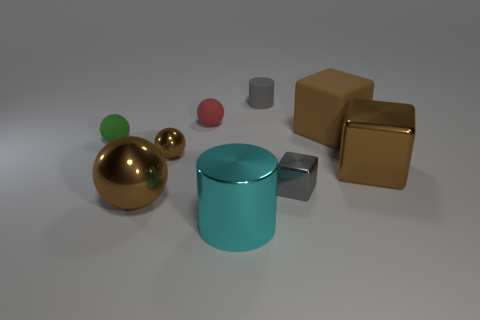Subtract all big blocks. How many blocks are left? 1 Subtract all red spheres. How many spheres are left? 3 Add 1 small brown metallic cylinders. How many objects exist? 10 Subtract all green cubes. Subtract all brown spheres. How many cubes are left? 3 Subtract 0 purple cylinders. How many objects are left? 9 Subtract all blocks. How many objects are left? 6 Subtract all big brown metallic balls. Subtract all small red rubber things. How many objects are left? 7 Add 9 small brown metallic balls. How many small brown metallic balls are left? 10 Add 3 tiny things. How many tiny things exist? 8 